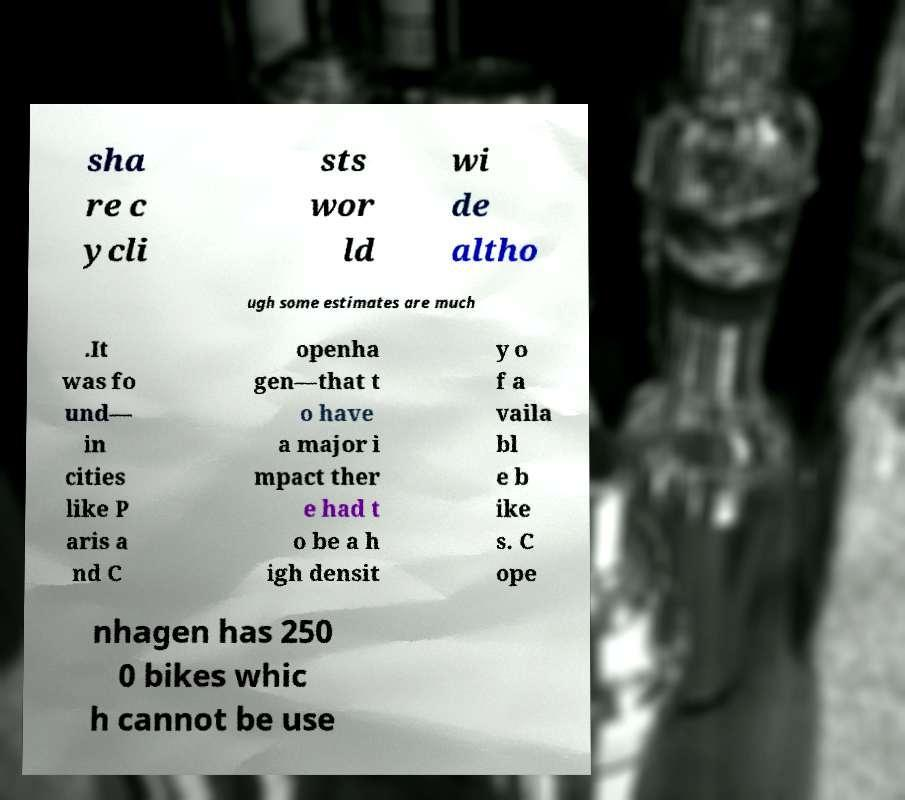Please read and relay the text visible in this image. What does it say? sha re c ycli sts wor ld wi de altho ugh some estimates are much .It was fo und— in cities like P aris a nd C openha gen—that t o have a major i mpact ther e had t o be a h igh densit y o f a vaila bl e b ike s. C ope nhagen has 250 0 bikes whic h cannot be use 